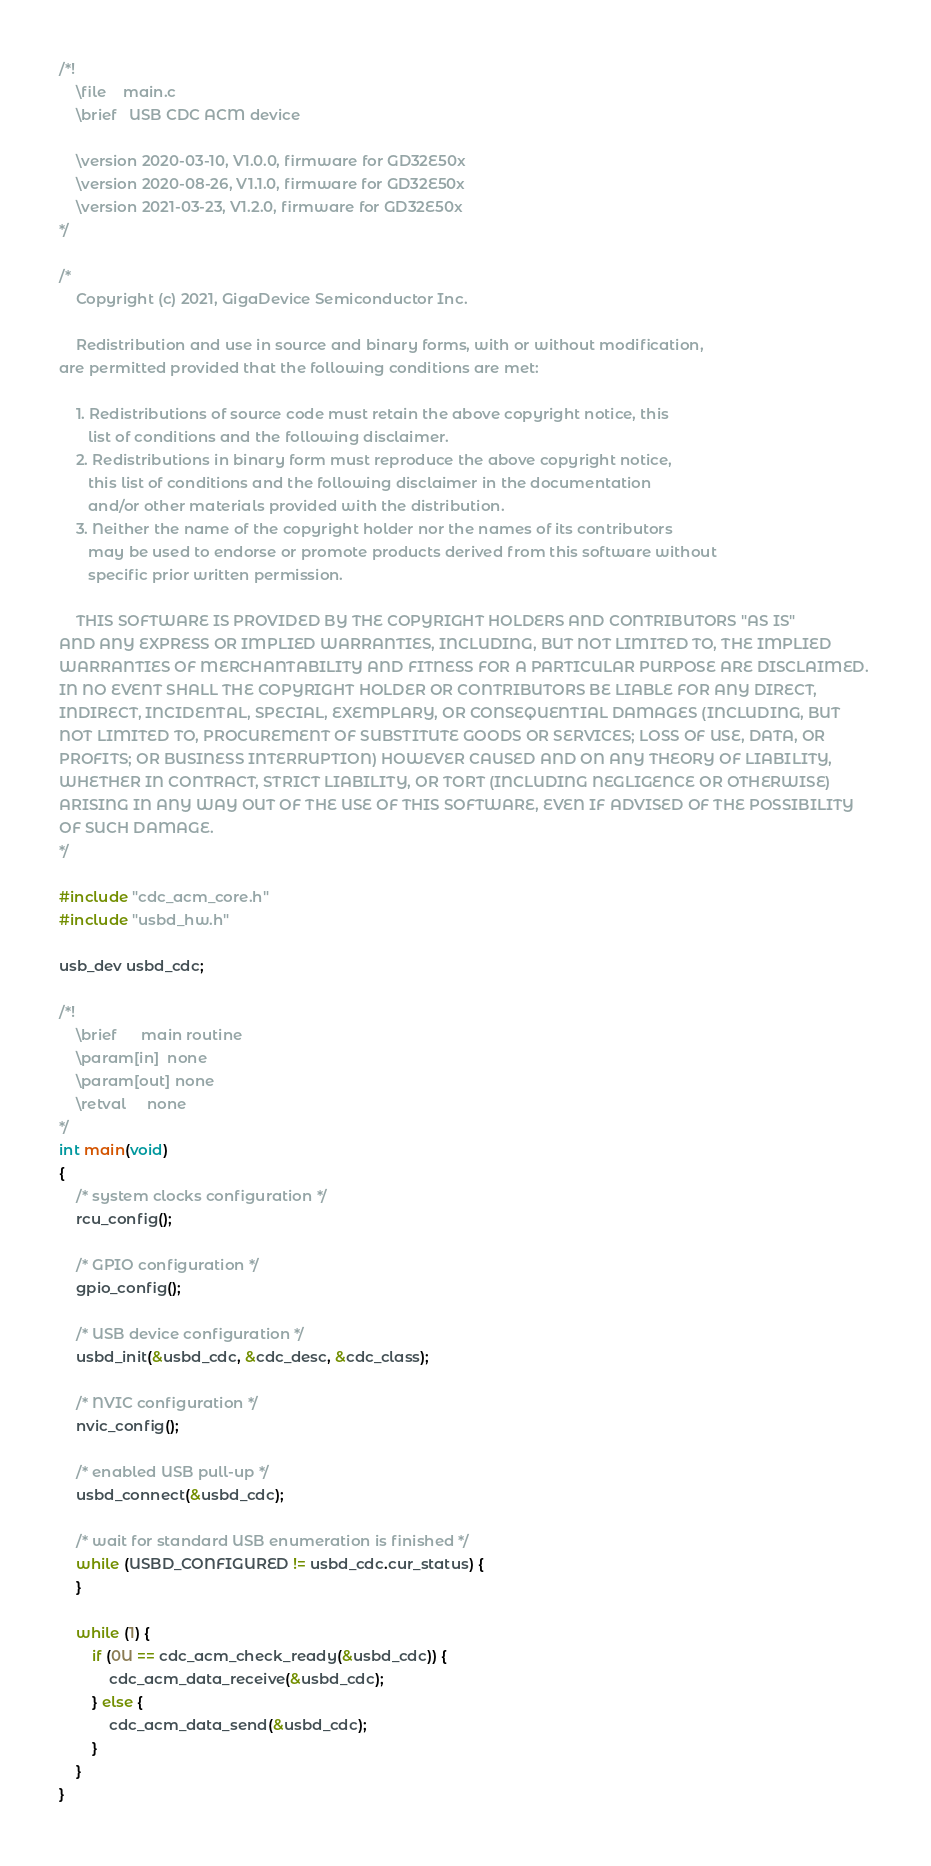<code> <loc_0><loc_0><loc_500><loc_500><_C_>/*!
    \file    main.c
    \brief   USB CDC ACM device

    \version 2020-03-10, V1.0.0, firmware for GD32E50x
    \version 2020-08-26, V1.1.0, firmware for GD32E50x
    \version 2021-03-23, V1.2.0, firmware for GD32E50x
*/

/*
    Copyright (c) 2021, GigaDevice Semiconductor Inc.

    Redistribution and use in source and binary forms, with or without modification, 
are permitted provided that the following conditions are met:

    1. Redistributions of source code must retain the above copyright notice, this 
       list of conditions and the following disclaimer.
    2. Redistributions in binary form must reproduce the above copyright notice, 
       this list of conditions and the following disclaimer in the documentation 
       and/or other materials provided with the distribution.
    3. Neither the name of the copyright holder nor the names of its contributors 
       may be used to endorse or promote products derived from this software without 
       specific prior written permission.

    THIS SOFTWARE IS PROVIDED BY THE COPYRIGHT HOLDERS AND CONTRIBUTORS "AS IS" 
AND ANY EXPRESS OR IMPLIED WARRANTIES, INCLUDING, BUT NOT LIMITED TO, THE IMPLIED 
WARRANTIES OF MERCHANTABILITY AND FITNESS FOR A PARTICULAR PURPOSE ARE DISCLAIMED. 
IN NO EVENT SHALL THE COPYRIGHT HOLDER OR CONTRIBUTORS BE LIABLE FOR ANY DIRECT, 
INDIRECT, INCIDENTAL, SPECIAL, EXEMPLARY, OR CONSEQUENTIAL DAMAGES (INCLUDING, BUT 
NOT LIMITED TO, PROCUREMENT OF SUBSTITUTE GOODS OR SERVICES; LOSS OF USE, DATA, OR 
PROFITS; OR BUSINESS INTERRUPTION) HOWEVER CAUSED AND ON ANY THEORY OF LIABILITY, 
WHETHER IN CONTRACT, STRICT LIABILITY, OR TORT (INCLUDING NEGLIGENCE OR OTHERWISE) 
ARISING IN ANY WAY OUT OF THE USE OF THIS SOFTWARE, EVEN IF ADVISED OF THE POSSIBILITY 
OF SUCH DAMAGE.
*/

#include "cdc_acm_core.h"
#include "usbd_hw.h"

usb_dev usbd_cdc;

/*!
    \brief      main routine
    \param[in]  none
    \param[out] none
    \retval     none
*/
int main(void)
{
    /* system clocks configuration */
    rcu_config();

    /* GPIO configuration */
    gpio_config();

    /* USB device configuration */
    usbd_init(&usbd_cdc, &cdc_desc, &cdc_class);

    /* NVIC configuration */
    nvic_config();

    /* enabled USB pull-up */
    usbd_connect(&usbd_cdc);

    /* wait for standard USB enumeration is finished */
    while (USBD_CONFIGURED != usbd_cdc.cur_status) {
    }

    while (1) {
        if (0U == cdc_acm_check_ready(&usbd_cdc)) {
            cdc_acm_data_receive(&usbd_cdc);
        } else {
            cdc_acm_data_send(&usbd_cdc);
        }
    }
}
</code> 